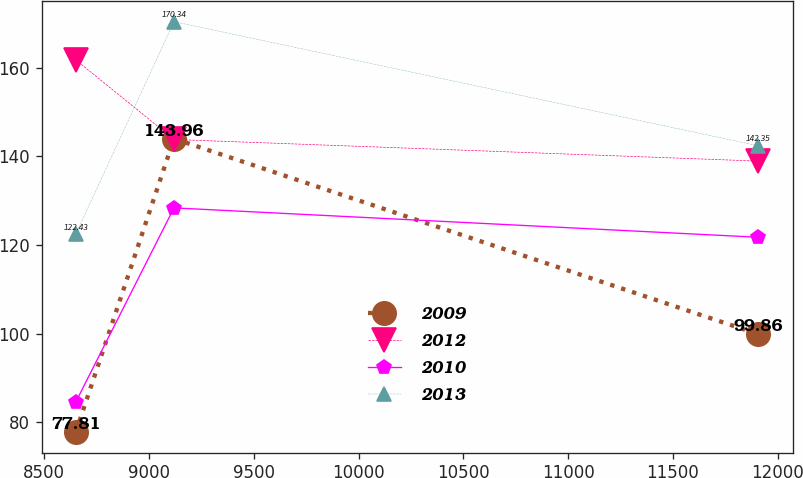Convert chart to OTSL. <chart><loc_0><loc_0><loc_500><loc_500><line_chart><ecel><fcel>2009<fcel>2012<fcel>2010<fcel>2013<nl><fcel>8650.93<fcel>77.81<fcel>161.72<fcel>84.57<fcel>122.43<nl><fcel>9119.6<fcel>143.96<fcel>143.77<fcel>128.35<fcel>170.34<nl><fcel>11908<fcel>99.86<fcel>138.9<fcel>121.72<fcel>142.35<nl></chart> 